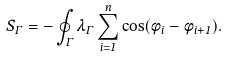<formula> <loc_0><loc_0><loc_500><loc_500>S _ { \Gamma } = - \oint _ { \Gamma } \lambda _ { \Gamma } \sum _ { i = 1 } ^ { n } \cos ( \phi _ { i } - \phi _ { i + 1 } ) .</formula> 